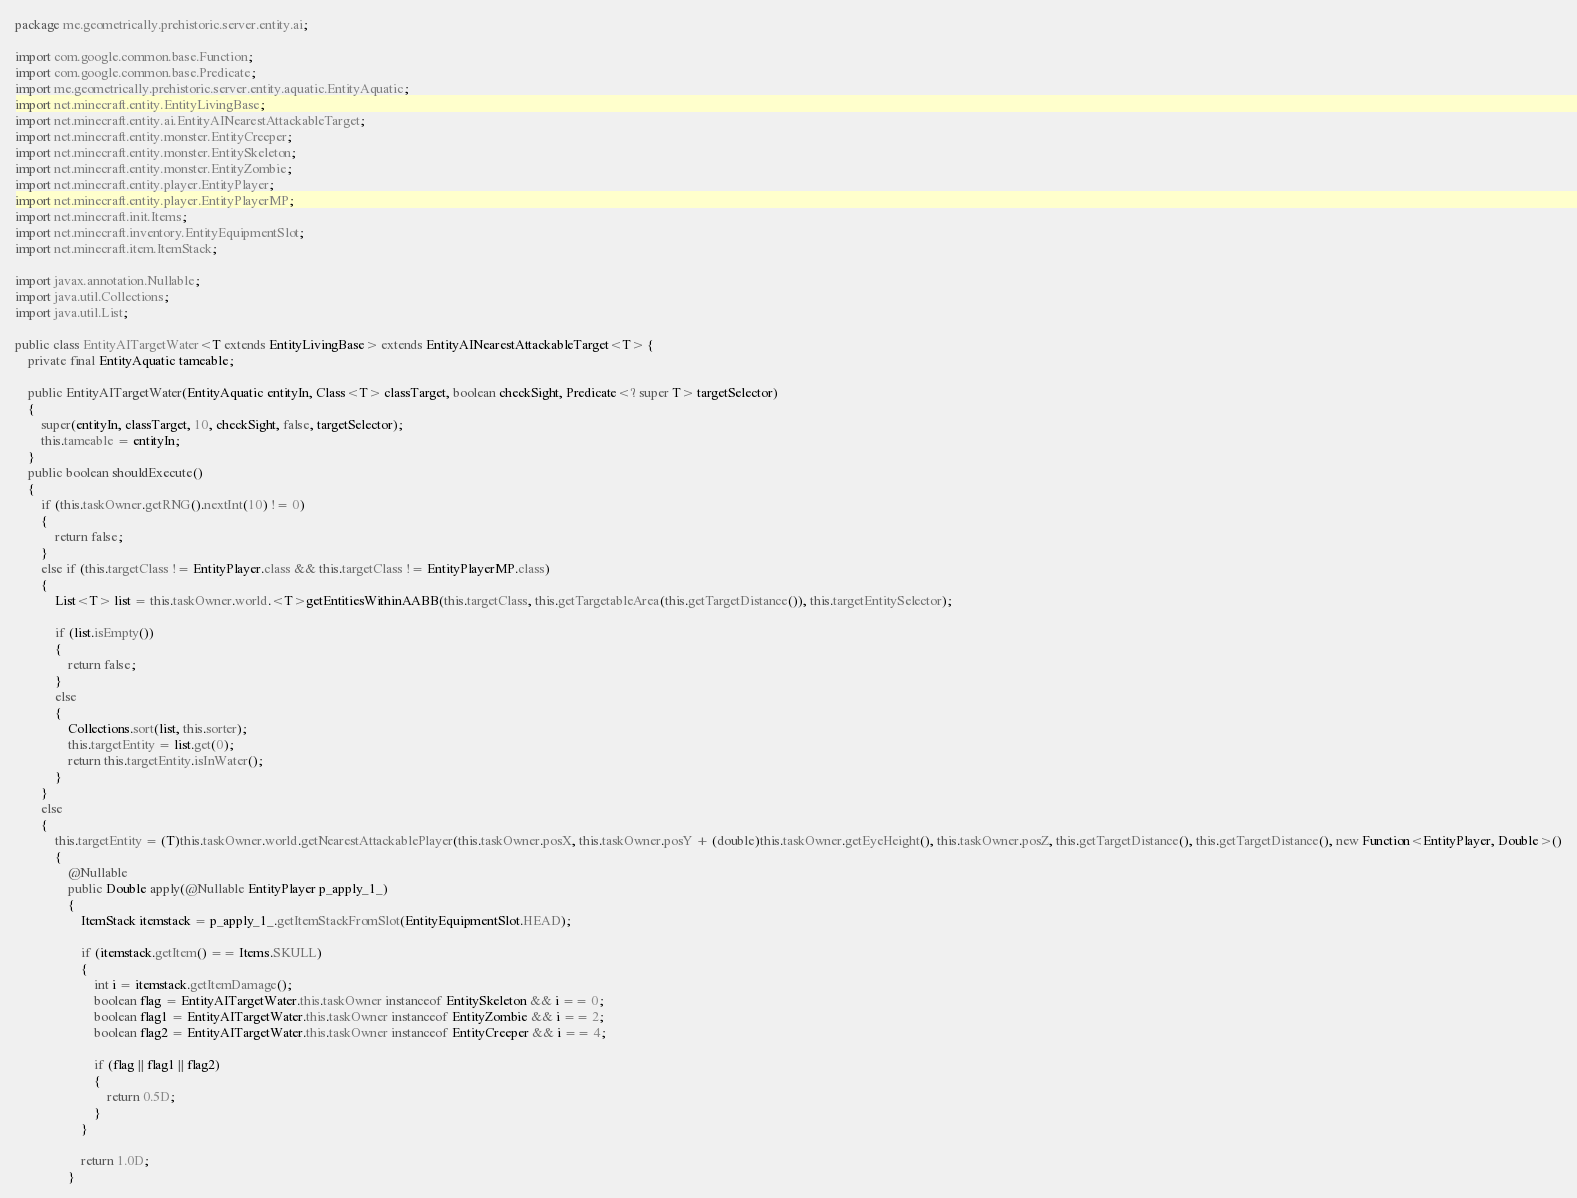<code> <loc_0><loc_0><loc_500><loc_500><_Java_>package me.geometrically.prehistoric.server.entity.ai;

import com.google.common.base.Function;
import com.google.common.base.Predicate;
import me.geometrically.prehistoric.server.entity.aquatic.EntityAquatic;
import net.minecraft.entity.EntityLivingBase;
import net.minecraft.entity.ai.EntityAINearestAttackableTarget;
import net.minecraft.entity.monster.EntityCreeper;
import net.minecraft.entity.monster.EntitySkeleton;
import net.minecraft.entity.monster.EntityZombie;
import net.minecraft.entity.player.EntityPlayer;
import net.minecraft.entity.player.EntityPlayerMP;
import net.minecraft.init.Items;
import net.minecraft.inventory.EntityEquipmentSlot;
import net.minecraft.item.ItemStack;

import javax.annotation.Nullable;
import java.util.Collections;
import java.util.List;

public class EntityAITargetWater<T extends EntityLivingBase> extends EntityAINearestAttackableTarget<T> {
    private final EntityAquatic tameable;

    public EntityAITargetWater(EntityAquatic entityIn, Class<T> classTarget, boolean checkSight, Predicate<? super T> targetSelector)
    {
        super(entityIn, classTarget, 10, checkSight, false, targetSelector);
        this.tameable = entityIn;
    }
    public boolean shouldExecute()
    {
        if (this.taskOwner.getRNG().nextInt(10) != 0)
        {
            return false;
        }
        else if (this.targetClass != EntityPlayer.class && this.targetClass != EntityPlayerMP.class)
        {
            List<T> list = this.taskOwner.world.<T>getEntitiesWithinAABB(this.targetClass, this.getTargetableArea(this.getTargetDistance()), this.targetEntitySelector);

            if (list.isEmpty())
            {
                return false;
            }
            else
            {
                Collections.sort(list, this.sorter);
                this.targetEntity = list.get(0);
                return this.targetEntity.isInWater();
            }
        }
        else
        {
            this.targetEntity = (T)this.taskOwner.world.getNearestAttackablePlayer(this.taskOwner.posX, this.taskOwner.posY + (double)this.taskOwner.getEyeHeight(), this.taskOwner.posZ, this.getTargetDistance(), this.getTargetDistance(), new Function<EntityPlayer, Double>()
            {
                @Nullable
                public Double apply(@Nullable EntityPlayer p_apply_1_)
                {
                    ItemStack itemstack = p_apply_1_.getItemStackFromSlot(EntityEquipmentSlot.HEAD);

                    if (itemstack.getItem() == Items.SKULL)
                    {
                        int i = itemstack.getItemDamage();
                        boolean flag = EntityAITargetWater.this.taskOwner instanceof EntitySkeleton && i == 0;
                        boolean flag1 = EntityAITargetWater.this.taskOwner instanceof EntityZombie && i == 2;
                        boolean flag2 = EntityAITargetWater.this.taskOwner instanceof EntityCreeper && i == 4;

                        if (flag || flag1 || flag2)
                        {
                            return 0.5D;
                        }
                    }

                    return 1.0D;
                }</code> 